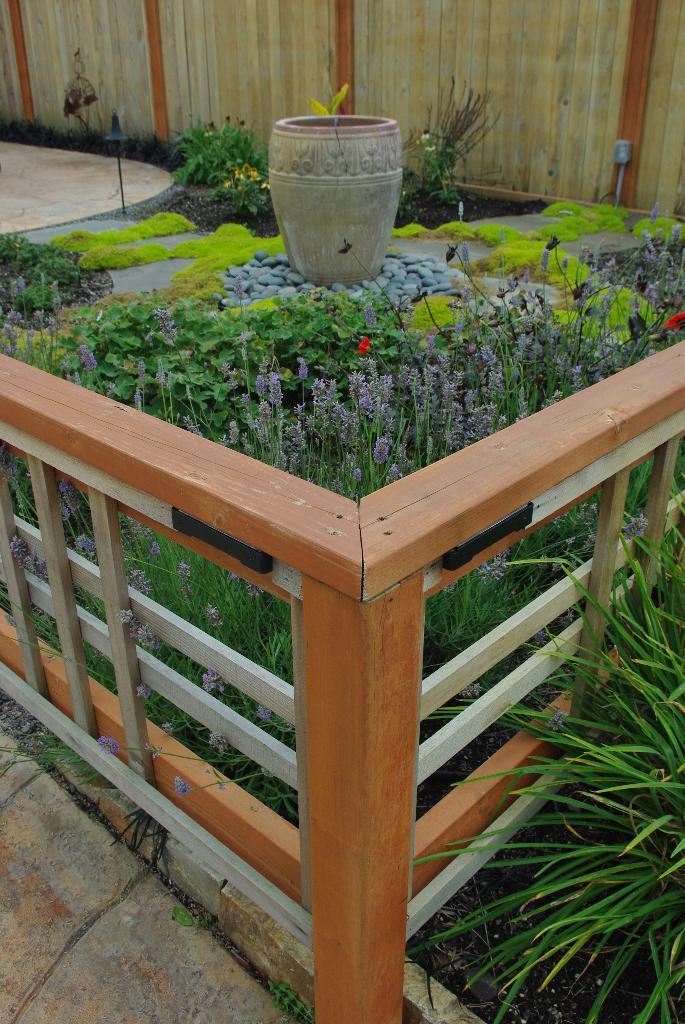What is located in the center of the image? There is a fence, a railing, and a pot with a plant in the center of the image. What type of plants can be seen in the image? There are plants, flowers, and a plant in a pot in the image. What type of ground is visible in the image? There is grass, soil, and stones in the image. Can you see a basketball game happening in the image? No, there is no basketball game or any reference to sports in the image. 